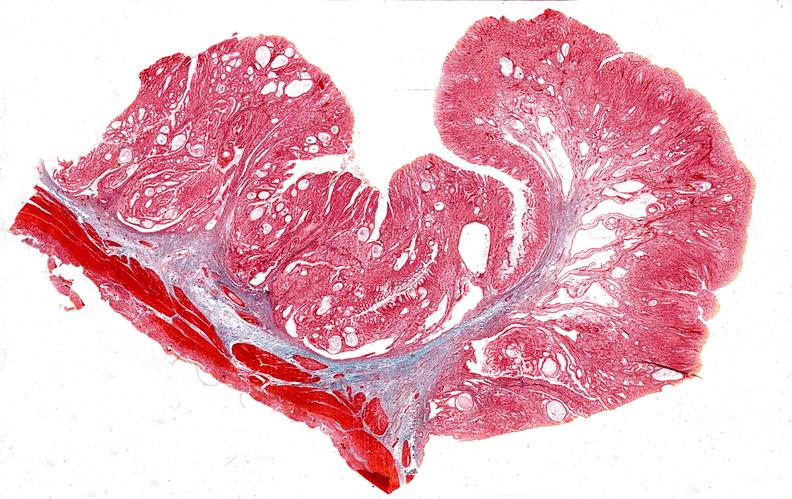where is this from?
Answer the question using a single word or phrase. Gastrointestinal system 